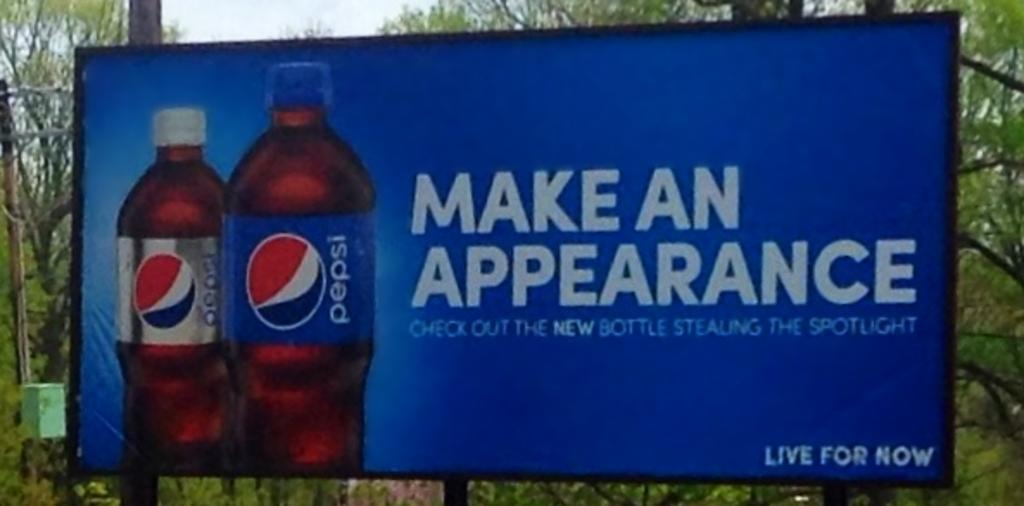What is the main subject in the image? There is a hoarding in the image. What can be seen in the background of the image? There are trees and the sky visible in the background of the image. What type of crown is depicted on the hoarding in the image? There is no crown present on the hoarding in the image. What message does the advertisement on the hoarding convey? The image does not contain an advertisement, as the main subject is a hoarding, which could potentially display an advertisement, but we do not have any information about its content. 